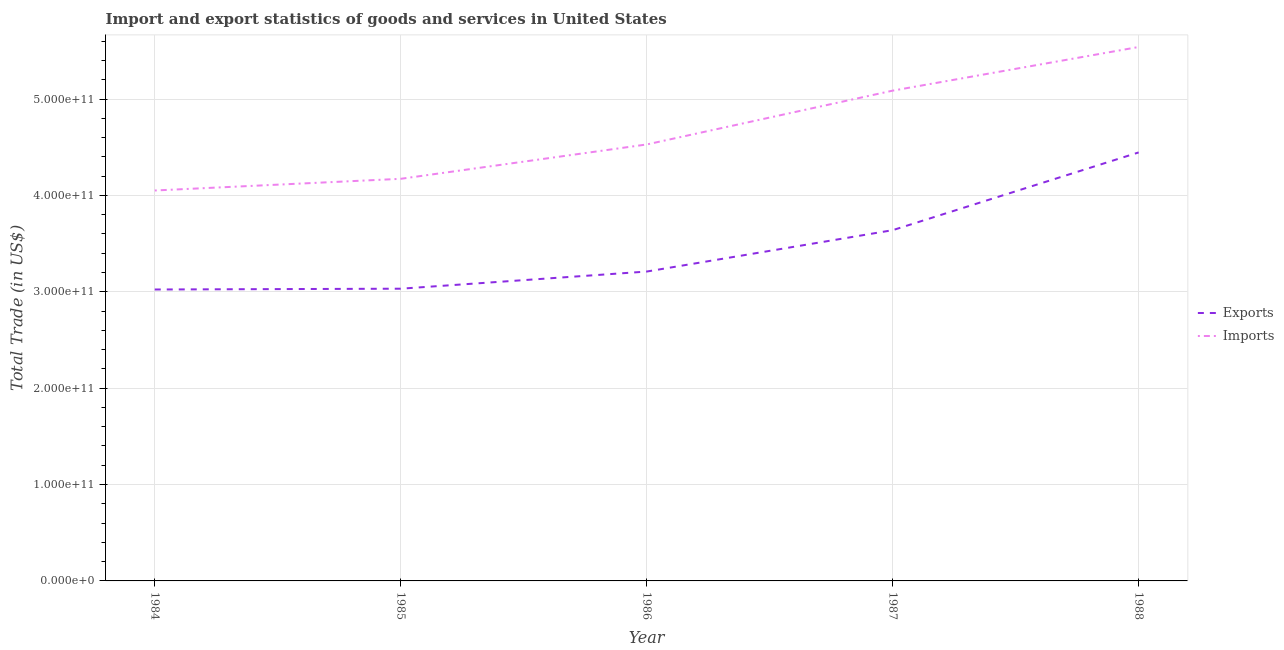What is the imports of goods and services in 1988?
Provide a succinct answer. 5.54e+11. Across all years, what is the maximum export of goods and services?
Your answer should be compact. 4.45e+11. Across all years, what is the minimum imports of goods and services?
Provide a succinct answer. 4.05e+11. In which year was the export of goods and services minimum?
Your answer should be very brief. 1984. What is the total imports of goods and services in the graph?
Make the answer very short. 2.34e+12. What is the difference between the imports of goods and services in 1986 and that in 1987?
Your answer should be compact. -5.58e+1. What is the difference between the export of goods and services in 1986 and the imports of goods and services in 1987?
Your answer should be compact. -1.88e+11. What is the average imports of goods and services per year?
Make the answer very short. 4.68e+11. In the year 1984, what is the difference between the export of goods and services and imports of goods and services?
Ensure brevity in your answer.  -1.03e+11. In how many years, is the imports of goods and services greater than 80000000000 US$?
Your answer should be compact. 5. What is the ratio of the export of goods and services in 1986 to that in 1987?
Offer a very short reply. 0.88. Is the export of goods and services in 1985 less than that in 1988?
Your answer should be compact. Yes. Is the difference between the export of goods and services in 1985 and 1986 greater than the difference between the imports of goods and services in 1985 and 1986?
Ensure brevity in your answer.  Yes. What is the difference between the highest and the second highest imports of goods and services?
Offer a terse response. 4.53e+1. What is the difference between the highest and the lowest export of goods and services?
Offer a terse response. 1.42e+11. Does the imports of goods and services monotonically increase over the years?
Your response must be concise. Yes. How many years are there in the graph?
Offer a terse response. 5. What is the difference between two consecutive major ticks on the Y-axis?
Make the answer very short. 1.00e+11. Does the graph contain any zero values?
Provide a succinct answer. No. How many legend labels are there?
Your answer should be very brief. 2. How are the legend labels stacked?
Provide a succinct answer. Vertical. What is the title of the graph?
Provide a succinct answer. Import and export statistics of goods and services in United States. Does "Exports" appear as one of the legend labels in the graph?
Your answer should be compact. Yes. What is the label or title of the Y-axis?
Provide a short and direct response. Total Trade (in US$). What is the Total Trade (in US$) of Exports in 1984?
Keep it short and to the point. 3.02e+11. What is the Total Trade (in US$) in Imports in 1984?
Make the answer very short. 4.05e+11. What is the Total Trade (in US$) in Exports in 1985?
Keep it short and to the point. 3.03e+11. What is the Total Trade (in US$) in Imports in 1985?
Provide a short and direct response. 4.17e+11. What is the Total Trade (in US$) in Exports in 1986?
Ensure brevity in your answer.  3.21e+11. What is the Total Trade (in US$) in Imports in 1986?
Your answer should be very brief. 4.53e+11. What is the Total Trade (in US$) in Exports in 1987?
Your response must be concise. 3.64e+11. What is the Total Trade (in US$) of Imports in 1987?
Your answer should be compact. 5.09e+11. What is the Total Trade (in US$) in Exports in 1988?
Your response must be concise. 4.45e+11. What is the Total Trade (in US$) in Imports in 1988?
Your answer should be compact. 5.54e+11. Across all years, what is the maximum Total Trade (in US$) of Exports?
Your response must be concise. 4.45e+11. Across all years, what is the maximum Total Trade (in US$) of Imports?
Your answer should be compact. 5.54e+11. Across all years, what is the minimum Total Trade (in US$) in Exports?
Give a very brief answer. 3.02e+11. Across all years, what is the minimum Total Trade (in US$) of Imports?
Your answer should be compact. 4.05e+11. What is the total Total Trade (in US$) in Exports in the graph?
Offer a very short reply. 1.74e+12. What is the total Total Trade (in US$) in Imports in the graph?
Offer a terse response. 2.34e+12. What is the difference between the Total Trade (in US$) in Exports in 1984 and that in 1985?
Make the answer very short. -8.26e+08. What is the difference between the Total Trade (in US$) in Imports in 1984 and that in 1985?
Make the answer very short. -1.21e+1. What is the difference between the Total Trade (in US$) in Exports in 1984 and that in 1986?
Your response must be concise. -1.86e+1. What is the difference between the Total Trade (in US$) in Imports in 1984 and that in 1986?
Your answer should be compact. -4.78e+1. What is the difference between the Total Trade (in US$) in Exports in 1984 and that in 1987?
Your answer should be very brief. -6.16e+1. What is the difference between the Total Trade (in US$) of Imports in 1984 and that in 1987?
Your answer should be compact. -1.04e+11. What is the difference between the Total Trade (in US$) of Exports in 1984 and that in 1988?
Your answer should be compact. -1.42e+11. What is the difference between the Total Trade (in US$) of Imports in 1984 and that in 1988?
Give a very brief answer. -1.49e+11. What is the difference between the Total Trade (in US$) in Exports in 1985 and that in 1986?
Keep it short and to the point. -1.78e+1. What is the difference between the Total Trade (in US$) in Imports in 1985 and that in 1986?
Provide a succinct answer. -3.56e+1. What is the difference between the Total Trade (in US$) in Exports in 1985 and that in 1987?
Keep it short and to the point. -6.07e+1. What is the difference between the Total Trade (in US$) in Imports in 1985 and that in 1987?
Your answer should be very brief. -9.15e+1. What is the difference between the Total Trade (in US$) in Exports in 1985 and that in 1988?
Provide a succinct answer. -1.41e+11. What is the difference between the Total Trade (in US$) in Imports in 1985 and that in 1988?
Keep it short and to the point. -1.37e+11. What is the difference between the Total Trade (in US$) in Exports in 1986 and that in 1987?
Provide a short and direct response. -4.29e+1. What is the difference between the Total Trade (in US$) of Imports in 1986 and that in 1987?
Offer a very short reply. -5.58e+1. What is the difference between the Total Trade (in US$) in Exports in 1986 and that in 1988?
Your answer should be very brief. -1.24e+11. What is the difference between the Total Trade (in US$) of Imports in 1986 and that in 1988?
Give a very brief answer. -1.01e+11. What is the difference between the Total Trade (in US$) in Exports in 1987 and that in 1988?
Keep it short and to the point. -8.07e+1. What is the difference between the Total Trade (in US$) in Imports in 1987 and that in 1988?
Give a very brief answer. -4.53e+1. What is the difference between the Total Trade (in US$) of Exports in 1984 and the Total Trade (in US$) of Imports in 1985?
Provide a succinct answer. -1.15e+11. What is the difference between the Total Trade (in US$) of Exports in 1984 and the Total Trade (in US$) of Imports in 1986?
Your answer should be compact. -1.50e+11. What is the difference between the Total Trade (in US$) in Exports in 1984 and the Total Trade (in US$) in Imports in 1987?
Give a very brief answer. -2.06e+11. What is the difference between the Total Trade (in US$) of Exports in 1984 and the Total Trade (in US$) of Imports in 1988?
Ensure brevity in your answer.  -2.52e+11. What is the difference between the Total Trade (in US$) of Exports in 1985 and the Total Trade (in US$) of Imports in 1986?
Your answer should be compact. -1.50e+11. What is the difference between the Total Trade (in US$) in Exports in 1985 and the Total Trade (in US$) in Imports in 1987?
Keep it short and to the point. -2.06e+11. What is the difference between the Total Trade (in US$) of Exports in 1985 and the Total Trade (in US$) of Imports in 1988?
Your answer should be very brief. -2.51e+11. What is the difference between the Total Trade (in US$) in Exports in 1986 and the Total Trade (in US$) in Imports in 1987?
Your answer should be compact. -1.88e+11. What is the difference between the Total Trade (in US$) in Exports in 1986 and the Total Trade (in US$) in Imports in 1988?
Your answer should be compact. -2.33e+11. What is the difference between the Total Trade (in US$) of Exports in 1987 and the Total Trade (in US$) of Imports in 1988?
Your answer should be compact. -1.90e+11. What is the average Total Trade (in US$) in Exports per year?
Your answer should be very brief. 3.47e+11. What is the average Total Trade (in US$) of Imports per year?
Give a very brief answer. 4.68e+11. In the year 1984, what is the difference between the Total Trade (in US$) of Exports and Total Trade (in US$) of Imports?
Make the answer very short. -1.03e+11. In the year 1985, what is the difference between the Total Trade (in US$) of Exports and Total Trade (in US$) of Imports?
Ensure brevity in your answer.  -1.14e+11. In the year 1986, what is the difference between the Total Trade (in US$) of Exports and Total Trade (in US$) of Imports?
Offer a very short reply. -1.32e+11. In the year 1987, what is the difference between the Total Trade (in US$) of Exports and Total Trade (in US$) of Imports?
Offer a terse response. -1.45e+11. In the year 1988, what is the difference between the Total Trade (in US$) in Exports and Total Trade (in US$) in Imports?
Provide a short and direct response. -1.09e+11. What is the ratio of the Total Trade (in US$) of Exports in 1984 to that in 1985?
Ensure brevity in your answer.  1. What is the ratio of the Total Trade (in US$) of Imports in 1984 to that in 1985?
Your response must be concise. 0.97. What is the ratio of the Total Trade (in US$) of Exports in 1984 to that in 1986?
Your response must be concise. 0.94. What is the ratio of the Total Trade (in US$) in Imports in 1984 to that in 1986?
Provide a succinct answer. 0.89. What is the ratio of the Total Trade (in US$) of Exports in 1984 to that in 1987?
Make the answer very short. 0.83. What is the ratio of the Total Trade (in US$) of Imports in 1984 to that in 1987?
Ensure brevity in your answer.  0.8. What is the ratio of the Total Trade (in US$) in Exports in 1984 to that in 1988?
Provide a succinct answer. 0.68. What is the ratio of the Total Trade (in US$) in Imports in 1984 to that in 1988?
Make the answer very short. 0.73. What is the ratio of the Total Trade (in US$) in Exports in 1985 to that in 1986?
Give a very brief answer. 0.94. What is the ratio of the Total Trade (in US$) of Imports in 1985 to that in 1986?
Provide a short and direct response. 0.92. What is the ratio of the Total Trade (in US$) of Exports in 1985 to that in 1987?
Your answer should be compact. 0.83. What is the ratio of the Total Trade (in US$) of Imports in 1985 to that in 1987?
Offer a terse response. 0.82. What is the ratio of the Total Trade (in US$) in Exports in 1985 to that in 1988?
Make the answer very short. 0.68. What is the ratio of the Total Trade (in US$) in Imports in 1985 to that in 1988?
Offer a terse response. 0.75. What is the ratio of the Total Trade (in US$) in Exports in 1986 to that in 1987?
Give a very brief answer. 0.88. What is the ratio of the Total Trade (in US$) in Imports in 1986 to that in 1987?
Provide a short and direct response. 0.89. What is the ratio of the Total Trade (in US$) in Exports in 1986 to that in 1988?
Your answer should be very brief. 0.72. What is the ratio of the Total Trade (in US$) in Imports in 1986 to that in 1988?
Your answer should be compact. 0.82. What is the ratio of the Total Trade (in US$) of Exports in 1987 to that in 1988?
Keep it short and to the point. 0.82. What is the ratio of the Total Trade (in US$) of Imports in 1987 to that in 1988?
Provide a short and direct response. 0.92. What is the difference between the highest and the second highest Total Trade (in US$) of Exports?
Your answer should be compact. 8.07e+1. What is the difference between the highest and the second highest Total Trade (in US$) of Imports?
Provide a short and direct response. 4.53e+1. What is the difference between the highest and the lowest Total Trade (in US$) in Exports?
Give a very brief answer. 1.42e+11. What is the difference between the highest and the lowest Total Trade (in US$) in Imports?
Offer a very short reply. 1.49e+11. 